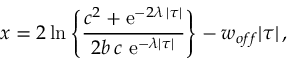<formula> <loc_0><loc_0><loc_500><loc_500>x = 2 { \, \ln } \left \{ { \frac { c ^ { 2 } + e ^ { - 2 \lambda \, | \tau | } } { 2 b \, c \ e ^ { - \lambda | \tau | } } } \right \} - w _ { o f f } | \tau | \, ,</formula> 